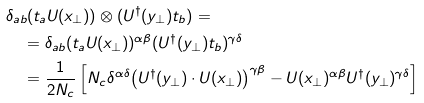<formula> <loc_0><loc_0><loc_500><loc_500>& { \delta } _ { a b } ( t _ { a } U ( x _ { \perp } ) ) \otimes ( U ^ { \dagger } ( y _ { \perp } ) t _ { b } ) = \\ & \quad = { \delta } _ { a b } ( t _ { a } U ( x _ { \perp } ) ) ^ { \alpha \beta } ( U ^ { \dagger } ( y _ { \perp } ) t _ { b } ) ^ { \gamma \delta } \\ & \quad = \frac { 1 } { 2 N _ { c } } \left [ N _ { c } { \delta } ^ { \alpha \delta } { \left ( U ^ { \dagger } ( y _ { \perp } ) \cdot U ( x _ { \perp } ) \right ) } ^ { \gamma \beta } - U ( x _ { \perp } ) ^ { \alpha \beta } U ^ { \dagger } ( y _ { \perp } ) ^ { \gamma \delta } \right ]</formula> 